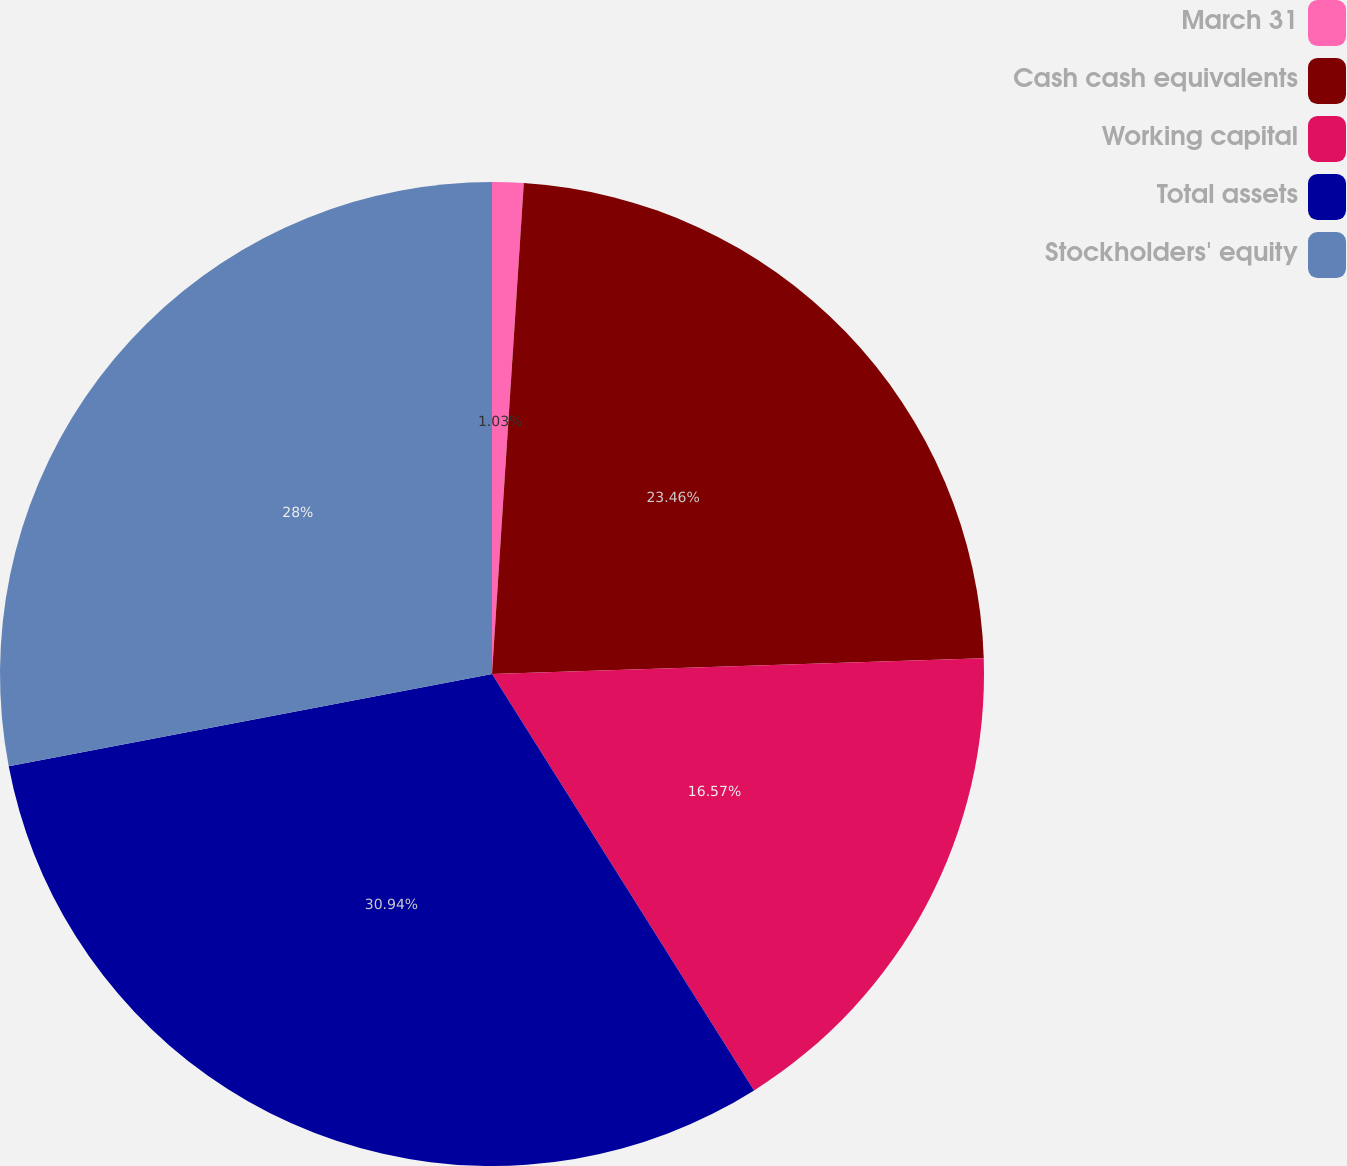Convert chart to OTSL. <chart><loc_0><loc_0><loc_500><loc_500><pie_chart><fcel>March 31<fcel>Cash cash equivalents<fcel>Working capital<fcel>Total assets<fcel>Stockholders' equity<nl><fcel>1.03%<fcel>23.46%<fcel>16.57%<fcel>30.94%<fcel>28.0%<nl></chart> 